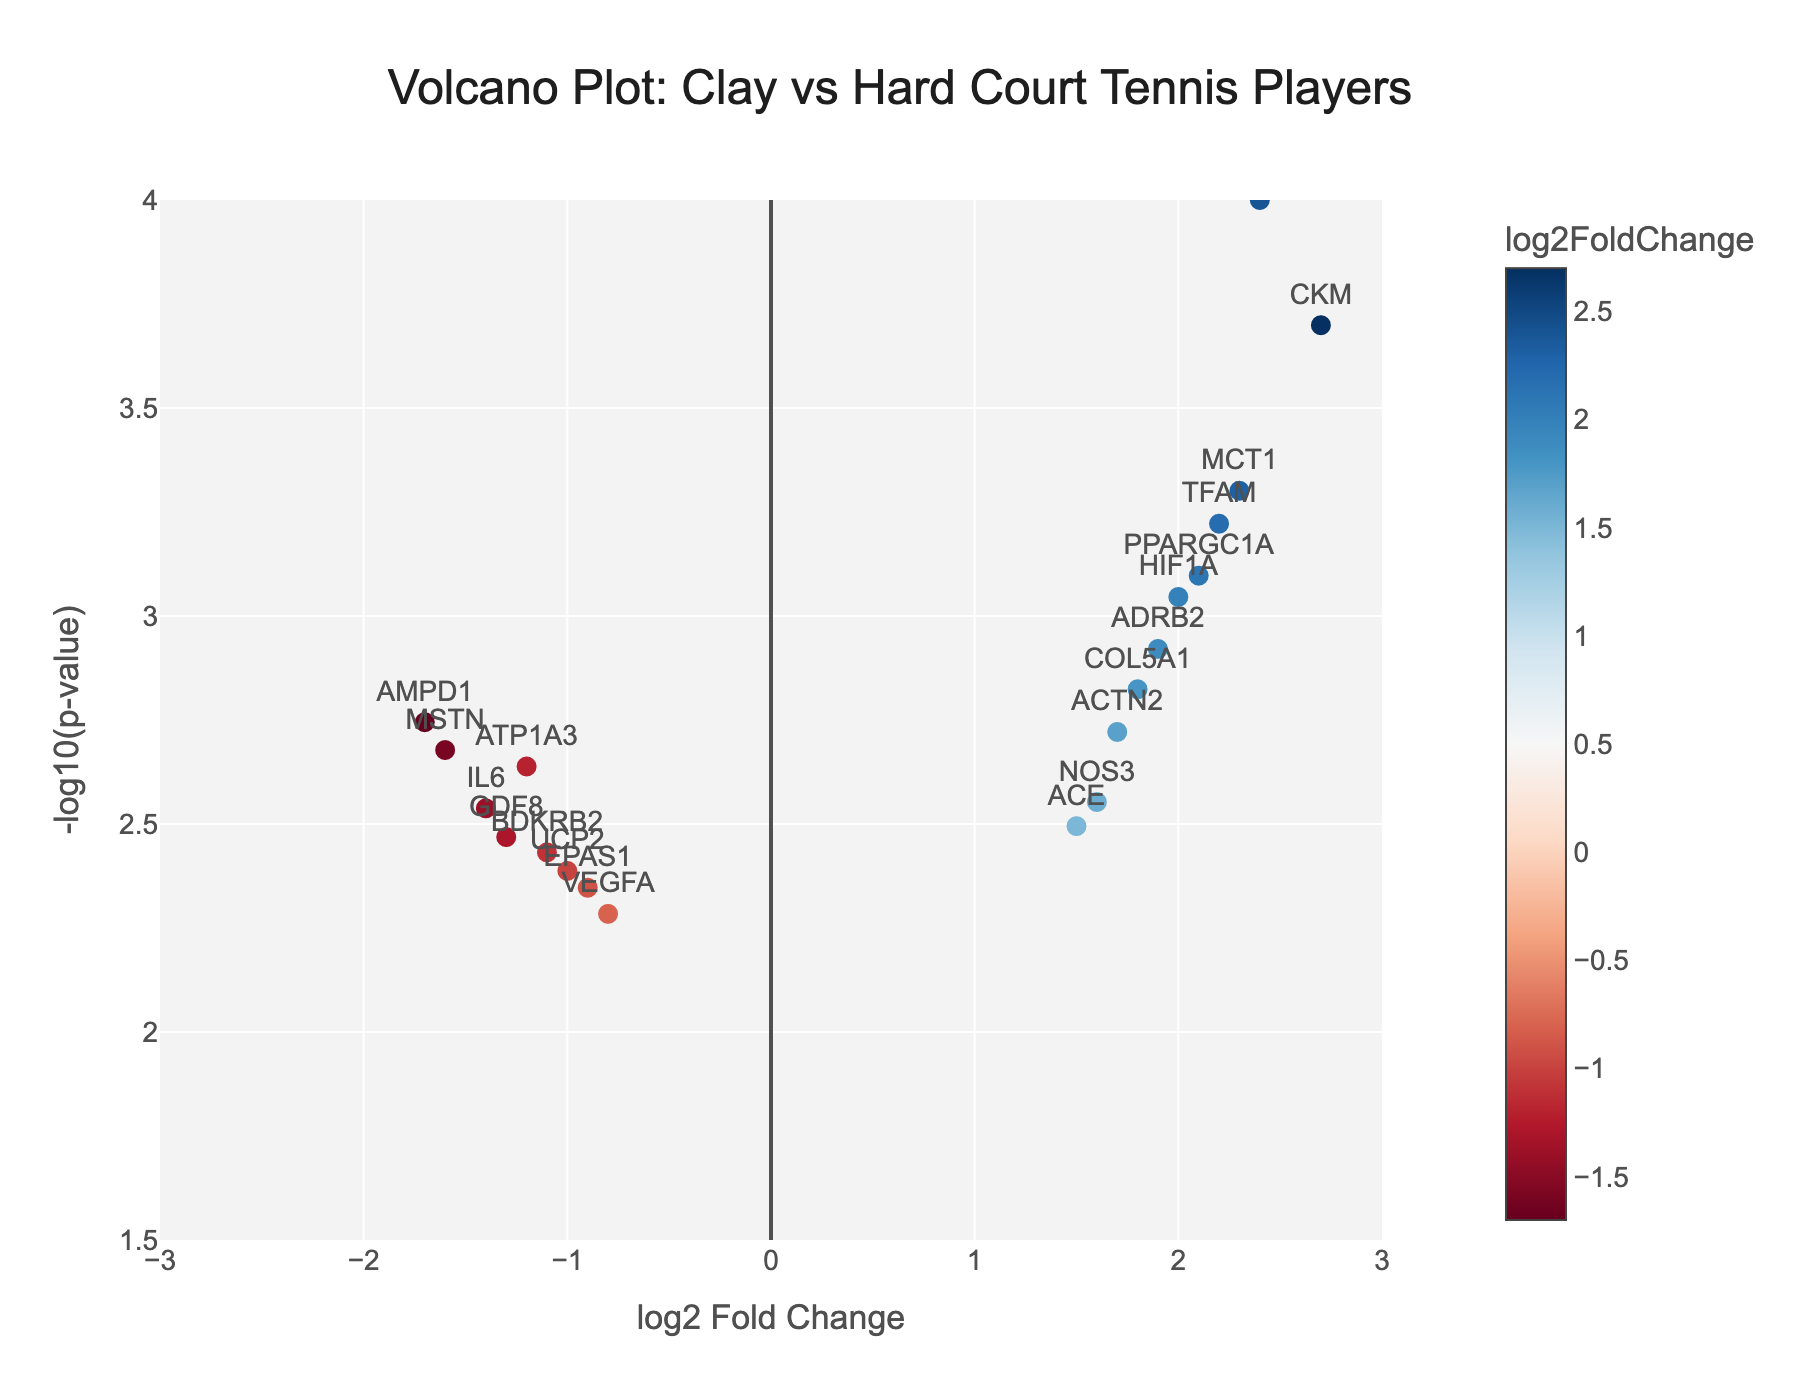What is the title of the plot? The title of the plot is located at the top center. It tells us the focus of the study.
Answer: Volcano Plot: Clay vs Hard Court Tennis Players What are the axes labels of the plot? The x-axis and y-axis labels are the names given to the axes to explain what they represent. The x-axis is "log2 Fold Change" and the y-axis is "-log10(p-value)."
Answer: log2 Fold Change, -log10(p-value) Which gene has the highest log2 Fold Change? To find the gene with the highest log2 Fold Change, look for the point farthest to the right on the x-axis. The gene labeled "CKM" is at the farthest right position.
Answer: CKM How many genes have a log2 Fold Change greater than 2? Count the number of points with log2 Fold Change values greater than 2. The genes ACTN3, CKM, and PPARGC1A have log2 Fold Change values > 2.
Answer: 3 What does the color of the markers indicate? The color scale on the right side of the plot shows that the markers' colors represent the log2 Fold Change values, with a range from negative to positive values.
Answer: log2 Fold Change Which gene has the highest statistical significance? The gene with the highest statistical significance will have the highest y-value because it corresponds to the lowest p-value. "ACTN3" is at the highest point on the y-axis.
Answer: ACTN3 Compare the log2 Fold Change of EPAS1 and VEGFA genes. Which one has a higher log2 Fold Change? EPAS1 has a log2 Fold Change of -0.9, and VEGFA has a log2 Fold Change of -0.8. By comparing these two values, VEGFA has a slightly higher log2 Fold Change.
Answer: VEGFA Which genes related to endurance (EPAS1, PPARGC1A, CKM) have significant changes, and are they upregulated or downregulated? Look for the points labeled EPAS1, PPARGC1A, and CKM on the plot. EPAS1 is downregulated with a negative log2 Fold Change, while PPARGC1A and CKM are upregulated with positive log2 Fold Changes.
Answer: EPAS1: downregulated, PPARGC1A and CKM: upregulated What is the log2 Fold Change and p-value for the gene ACTN3? Find the point labeled "ACTN3" on the plot and refer to its hover text. The hover text shows log2 Fold Change of 2.4 and p-value of 0.0001.
Answer: log2 Fold Change: 2.4, p-value: 0.0001 Are there more genes upregulated or downregulated in this study? Upregulated genes have positive log2 Fold Change values, and downregulated genes have negative values. Count positive and negative log2 Fold Change values. There are 9 downregulated and 11 upregulated genes, thus more upregulated.
Answer: Upregulated 